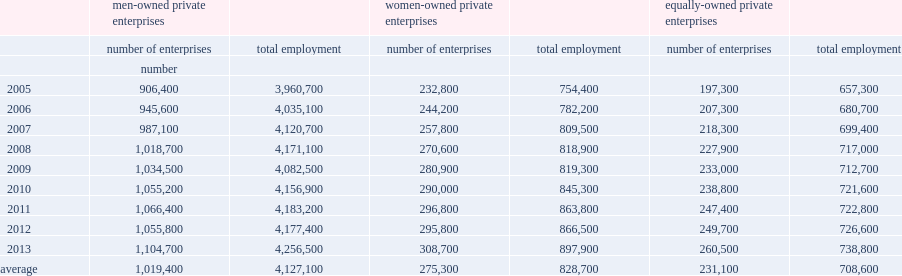Over the period from 2005 to 2013, how many men-owned enterprises employed workers on an annual basis? 1019400.0. Over the period from 2005 to 2013, how many workers on an annual basis did men-owned enterprises employ? 4127100.0. What was the number of women-owned enterprises? 275300.0. What was the number of women-owned associated was employment? 828700.0. 